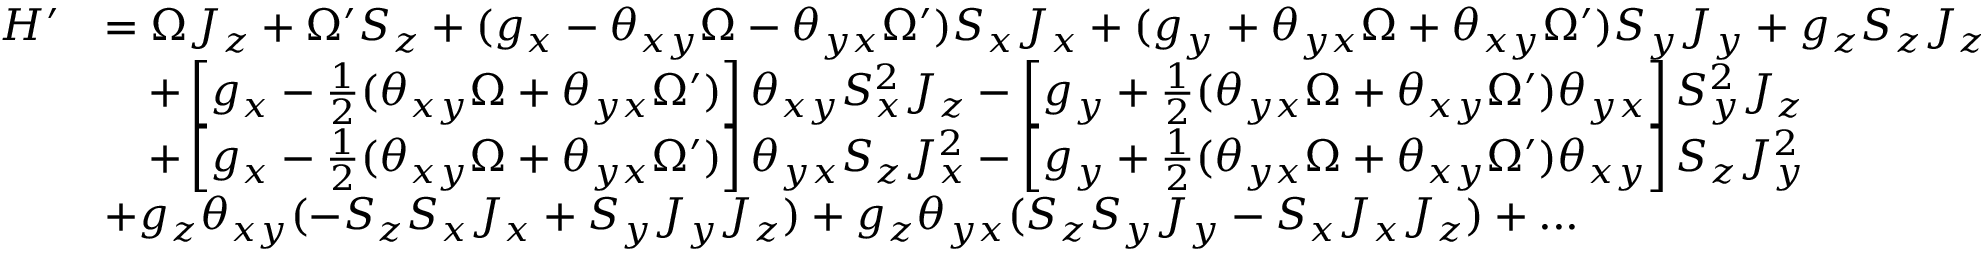Convert formula to latex. <formula><loc_0><loc_0><loc_500><loc_500>\begin{array} { r l } { H ^ { \prime } } & { = \Omega J _ { z } + \Omega ^ { \prime } S _ { z } + ( g _ { x } - \theta _ { x y } \Omega - \theta _ { y x } \Omega ^ { \prime } ) S _ { x } J _ { x } + ( g _ { y } + \theta _ { y x } \Omega + \theta _ { x y } \Omega ^ { \prime } ) S _ { y } J _ { y } + g _ { z } S _ { z } J _ { z } } \\ & { \quad + \left [ g _ { x } - \frac { 1 } { 2 } ( \theta _ { x y } \Omega + \theta _ { y x } \Omega ^ { \prime } ) \right ] \theta _ { x y } S _ { x } ^ { 2 } J _ { z } - \left [ g _ { y } + \frac { 1 } { 2 } ( \theta _ { y x } \Omega + \theta _ { x y } \Omega ^ { \prime } ) \theta _ { y x } \right ] S _ { y } ^ { 2 } J _ { z } } \\ & { \quad + \left [ g _ { x } - \frac { 1 } { 2 } ( \theta _ { x y } \Omega + \theta _ { y x } \Omega ^ { \prime } ) \right ] \theta _ { y x } S _ { z } J _ { x } ^ { 2 } - \left [ g _ { y } + \frac { 1 } { 2 } ( \theta _ { y x } \Omega + \theta _ { x y } \Omega ^ { \prime } ) \theta _ { x y } \right ] S _ { z } J _ { y } ^ { 2 } } \\ & { + g _ { z } \theta _ { x y } ( - S _ { z } S _ { x } J _ { x } + S _ { y } J _ { y } J _ { z } ) + g _ { z } \theta _ { y x } ( S _ { z } S _ { y } J _ { y } - S _ { x } J _ { x } J _ { z } ) + \dots } \end{array}</formula> 